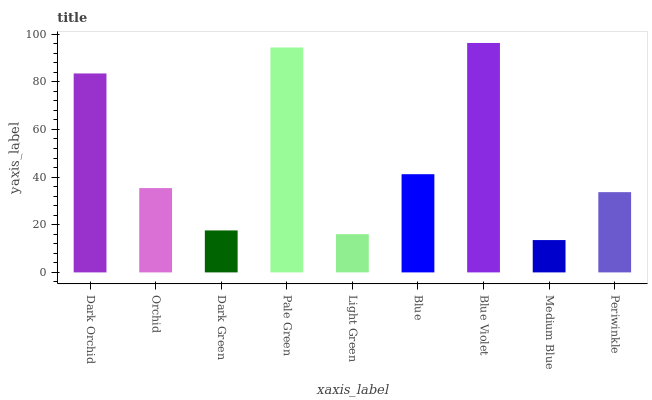Is Medium Blue the minimum?
Answer yes or no. Yes. Is Blue Violet the maximum?
Answer yes or no. Yes. Is Orchid the minimum?
Answer yes or no. No. Is Orchid the maximum?
Answer yes or no. No. Is Dark Orchid greater than Orchid?
Answer yes or no. Yes. Is Orchid less than Dark Orchid?
Answer yes or no. Yes. Is Orchid greater than Dark Orchid?
Answer yes or no. No. Is Dark Orchid less than Orchid?
Answer yes or no. No. Is Orchid the high median?
Answer yes or no. Yes. Is Orchid the low median?
Answer yes or no. Yes. Is Periwinkle the high median?
Answer yes or no. No. Is Blue Violet the low median?
Answer yes or no. No. 